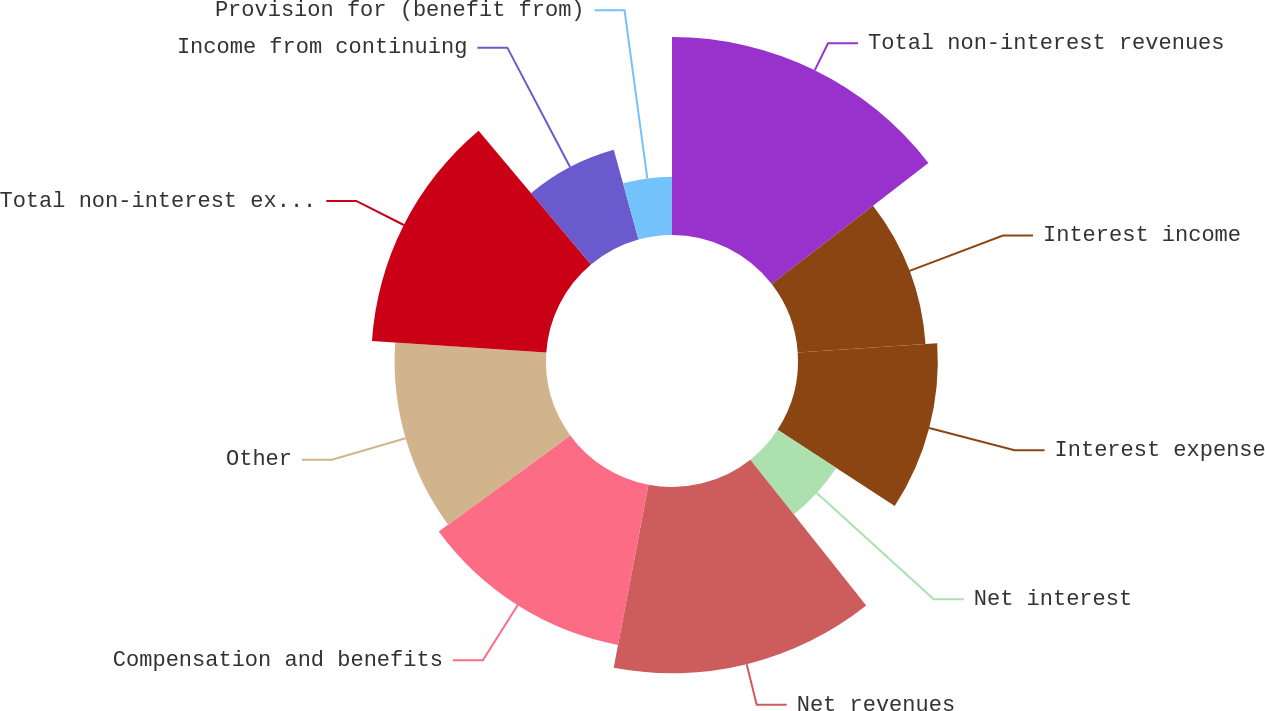<chart> <loc_0><loc_0><loc_500><loc_500><pie_chart><fcel>Total non-interest revenues<fcel>Interest income<fcel>Interest expense<fcel>Net interest<fcel>Net revenues<fcel>Compensation and benefits<fcel>Other<fcel>Total non-interest expenses<fcel>Income from continuing<fcel>Provision for (benefit from)<nl><fcel>14.53%<fcel>9.4%<fcel>10.26%<fcel>5.13%<fcel>13.67%<fcel>11.96%<fcel>11.11%<fcel>12.82%<fcel>6.84%<fcel>4.28%<nl></chart> 